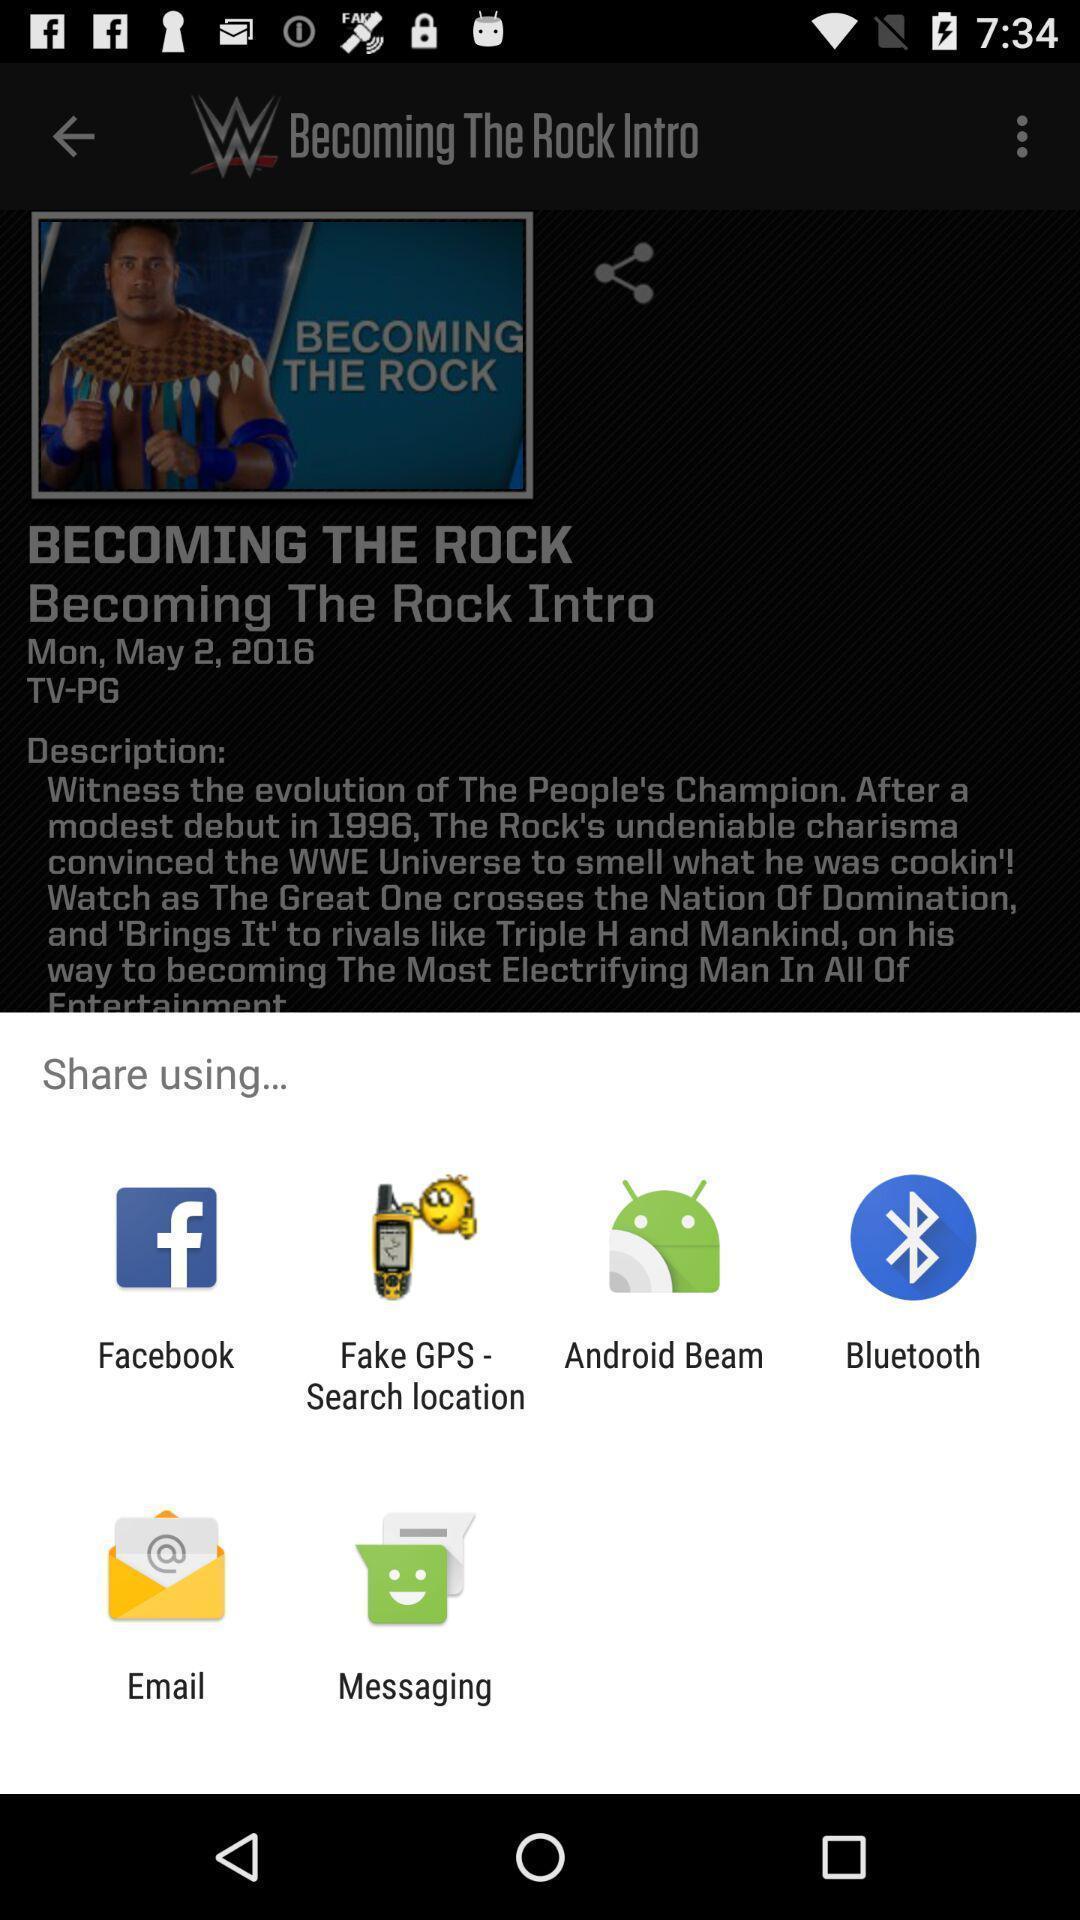Give me a narrative description of this picture. Popup to share in the sports streaming app. 